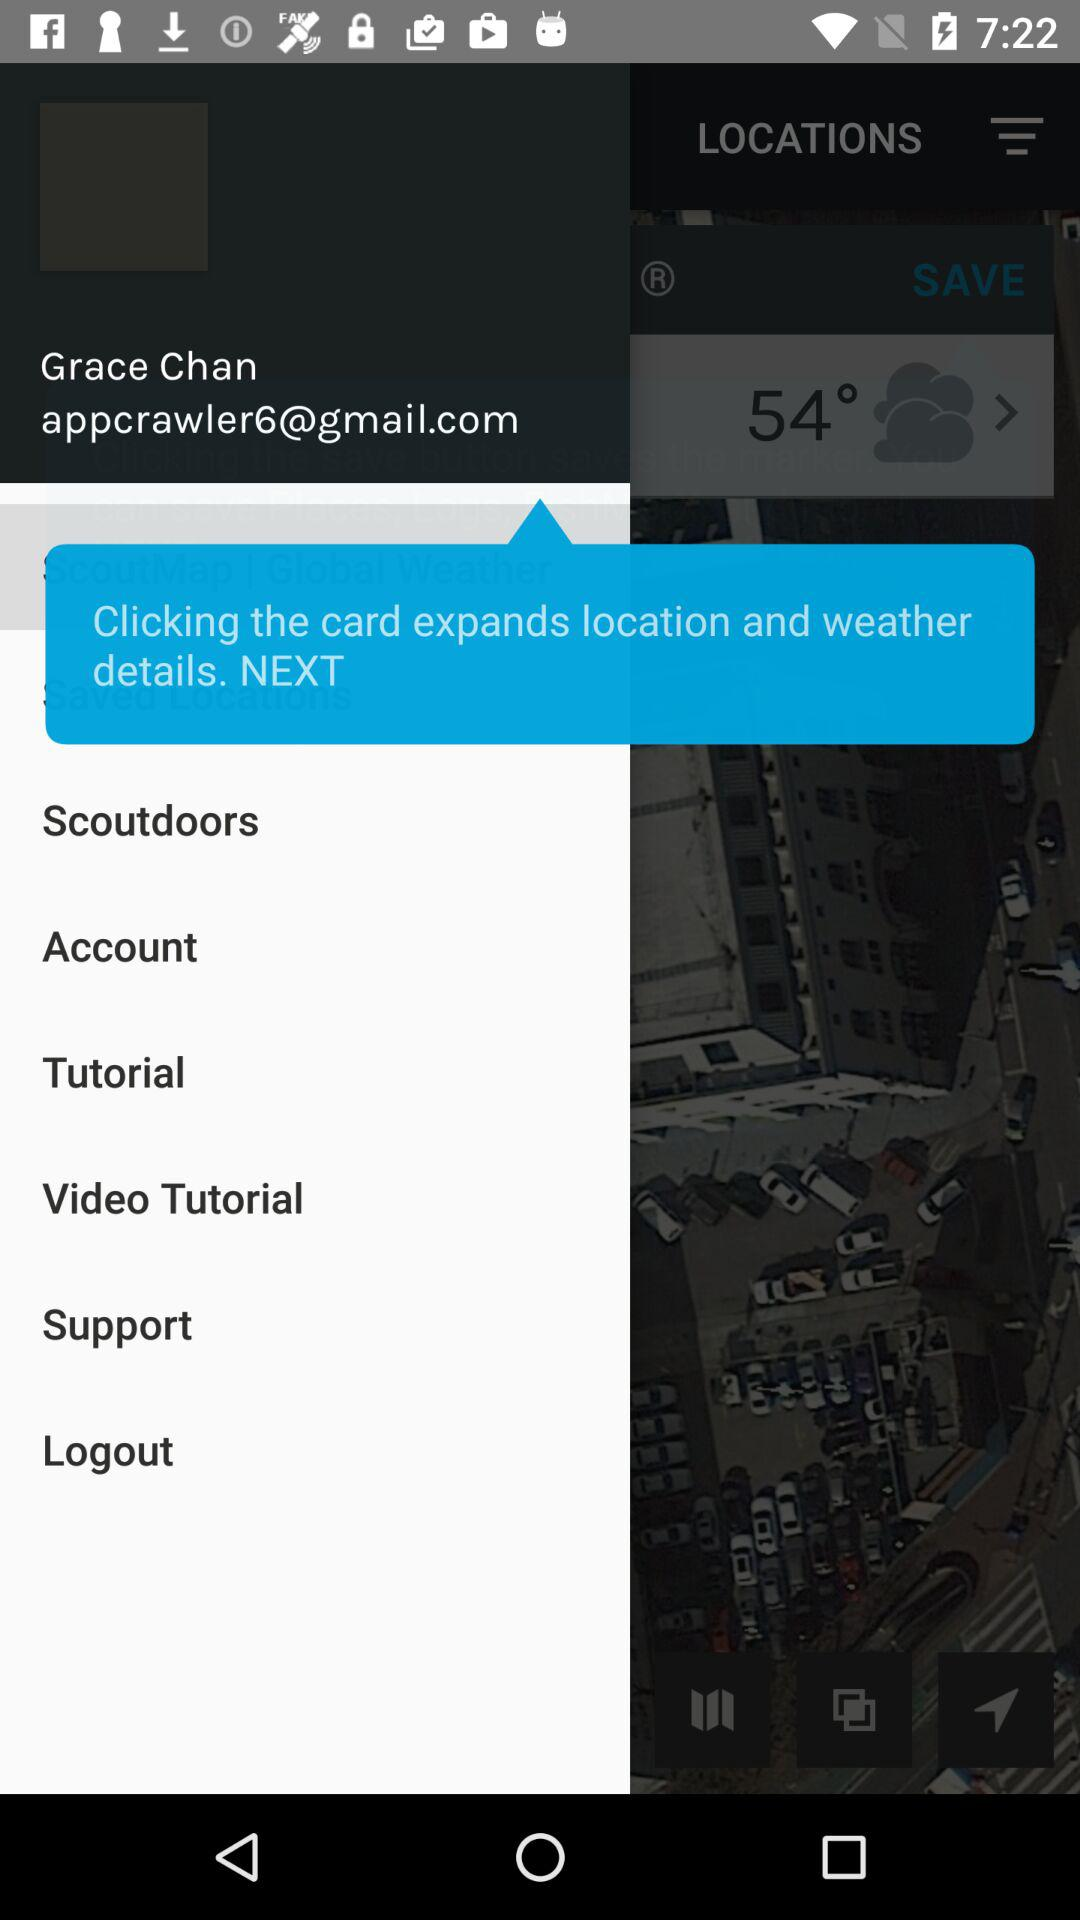What is the email address of the user? The email address is appcrawler6@gmail.com. 